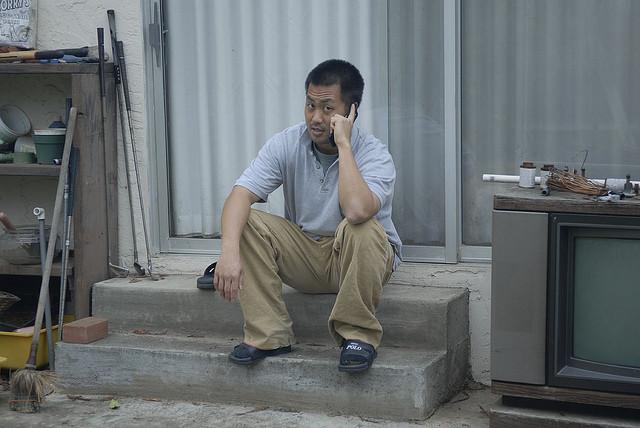Is the man sad?
Answer briefly. No. Is there a TV in the picture?
Answer briefly. Yes. Is the man wearing flip flops?
Short answer required. Yes. 